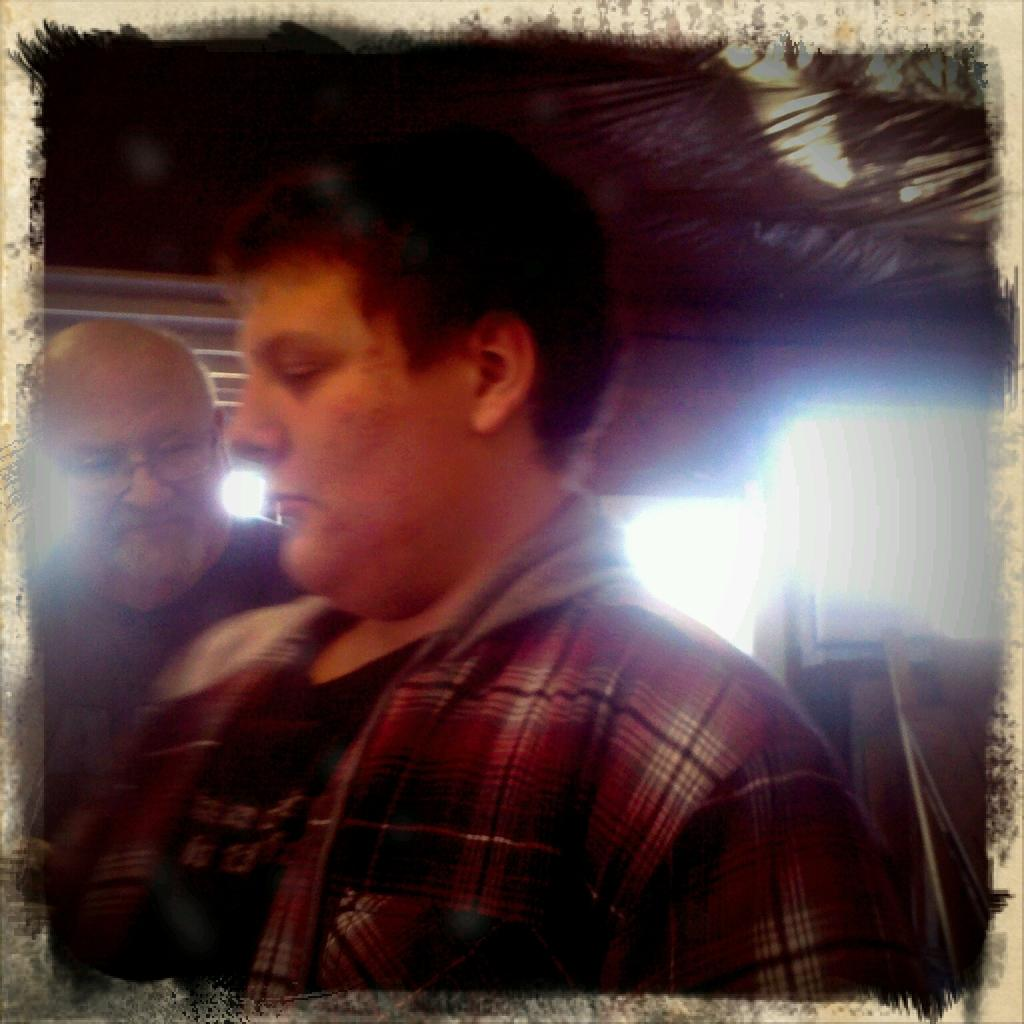How many people are in the image? There are two persons in the image. What can be seen in the background of the image? There are lights visible in the image, and it appears to be on a rooftop. How is the image presented? The image appears to be in a photo frame. How many rings can be seen on the person's finger in the image? There are no rings visible on any person's finger in the image. What is the level of noise in the image? The level of noise cannot be determined from the image, as it is a still photograph. 